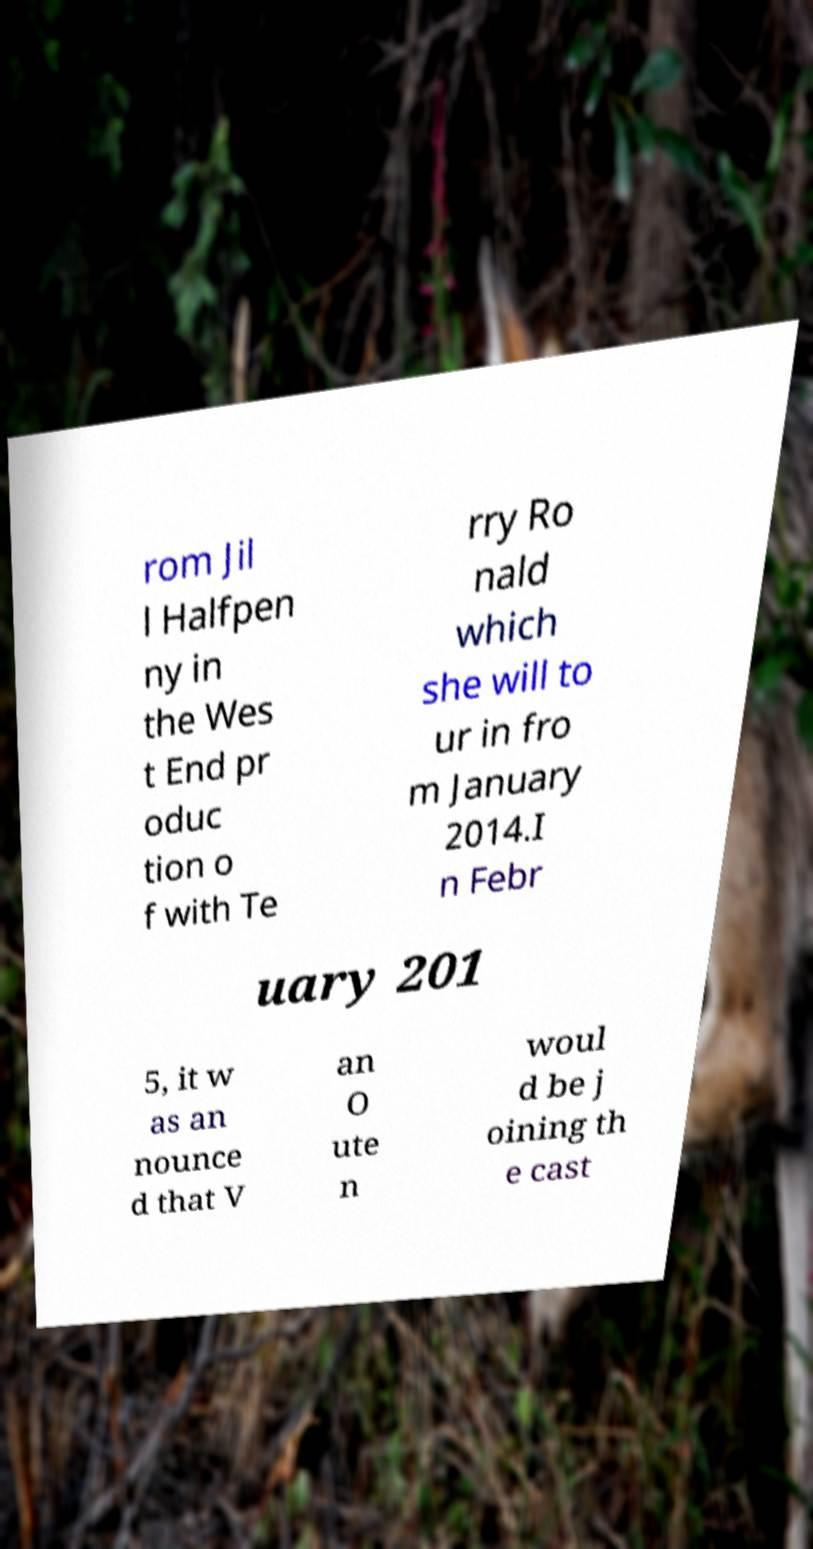There's text embedded in this image that I need extracted. Can you transcribe it verbatim? rom Jil l Halfpen ny in the Wes t End pr oduc tion o f with Te rry Ro nald which she will to ur in fro m January 2014.I n Febr uary 201 5, it w as an nounce d that V an O ute n woul d be j oining th e cast 